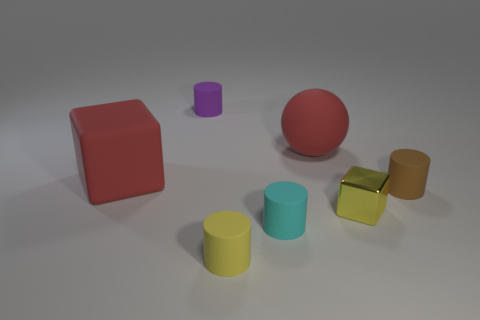Subtract all small yellow cylinders. How many cylinders are left? 3 Add 3 cyan matte cylinders. How many objects exist? 10 Subtract all brown cylinders. How many cylinders are left? 3 Subtract all spheres. How many objects are left? 6 Subtract all cyan blocks. Subtract all green spheres. How many blocks are left? 2 Subtract all small cyan matte balls. Subtract all tiny cyan cylinders. How many objects are left? 6 Add 4 small cyan rubber objects. How many small cyan rubber objects are left? 5 Add 7 brown matte objects. How many brown matte objects exist? 8 Subtract 1 brown cylinders. How many objects are left? 6 Subtract 1 cubes. How many cubes are left? 1 